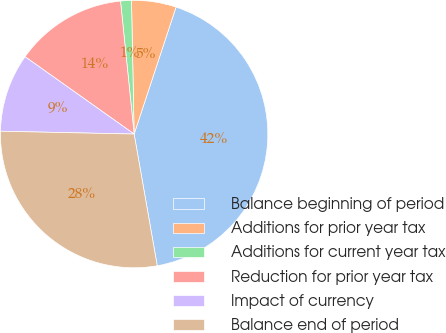Convert chart to OTSL. <chart><loc_0><loc_0><loc_500><loc_500><pie_chart><fcel>Balance beginning of period<fcel>Additions for prior year tax<fcel>Additions for current year tax<fcel>Reduction for prior year tax<fcel>Impact of currency<fcel>Balance end of period<nl><fcel>42.16%<fcel>5.39%<fcel>1.31%<fcel>13.56%<fcel>9.48%<fcel>28.1%<nl></chart> 